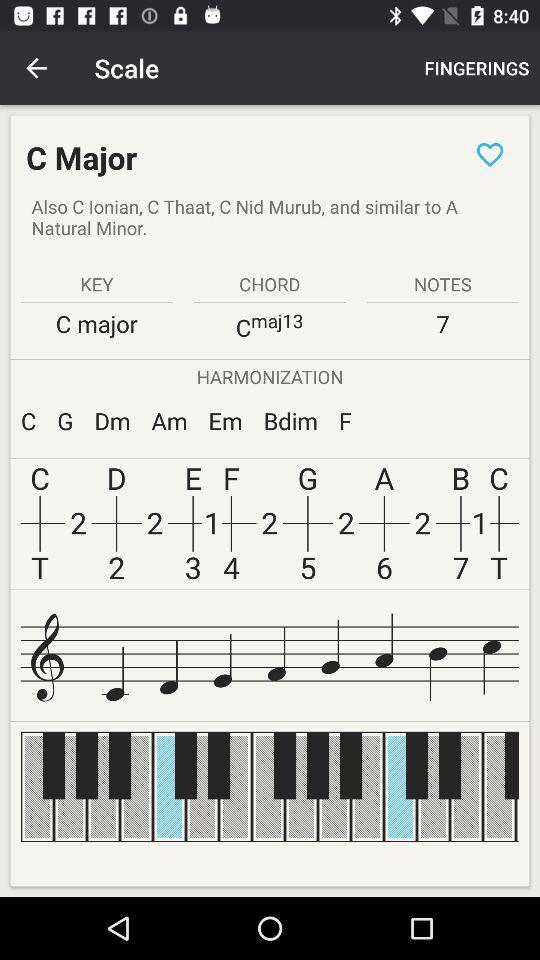What is the name of the application?
When the provided information is insufficient, respond with <no answer>. <no answer> 